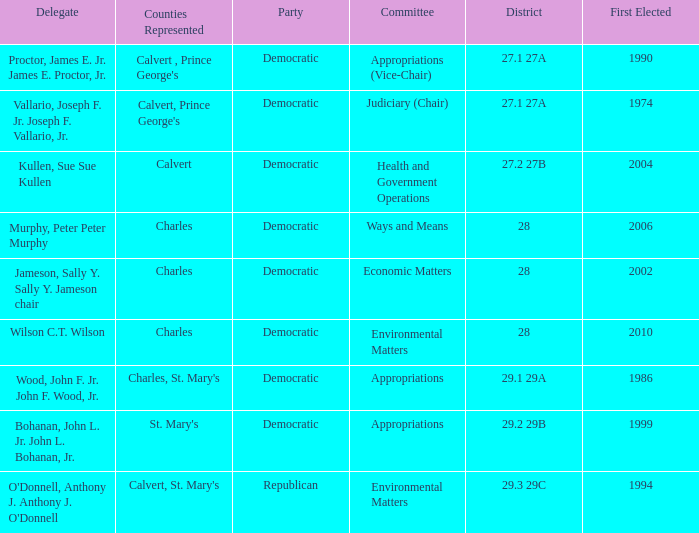Which was the district that had first elected greater than 2006 and is democratic? 28.0. 